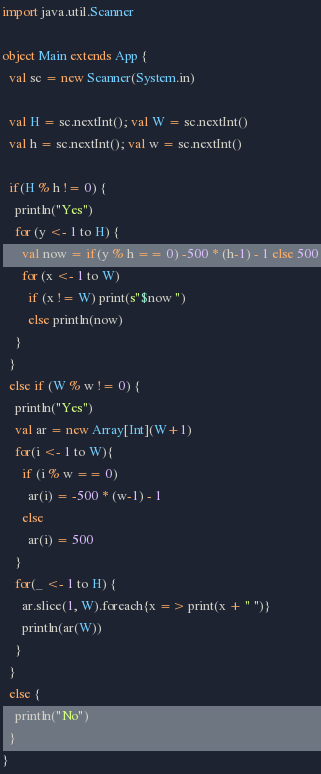<code> <loc_0><loc_0><loc_500><loc_500><_Scala_>import java.util.Scanner

object Main extends App {
  val sc = new Scanner(System.in)

  val H = sc.nextInt(); val W = sc.nextInt()
  val h = sc.nextInt(); val w = sc.nextInt()

  if(H % h != 0) {
    println("Yes")
    for (y <- 1 to H) {
      val now = if(y % h == 0) -500 * (h-1) - 1 else 500
      for (x <- 1 to W)
        if (x != W) print(s"$now ")
        else println(now)
    }
  }
  else if (W % w != 0) {
    println("Yes")
    val ar = new Array[Int](W+1)
    for(i <- 1 to W){
      if (i % w == 0)
        ar(i) = -500 * (w-1) - 1
      else
        ar(i) = 500
    }
    for(_ <- 1 to H) {
      ar.slice(1, W).foreach{x => print(x + " ")}
      println(ar(W))
    }
  }
  else {
    println("No")
  }
}
</code> 